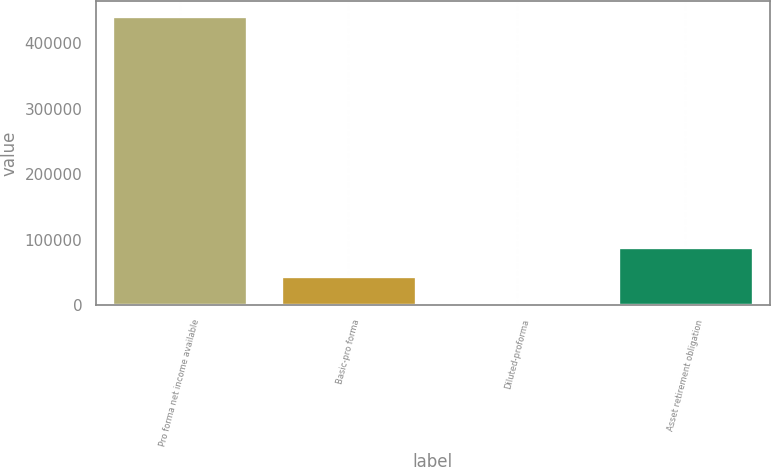Convert chart to OTSL. <chart><loc_0><loc_0><loc_500><loc_500><bar_chart><fcel>Pro forma net income available<fcel>Basic-pro forma<fcel>Diluted-proforma<fcel>Asset retirement obligation<nl><fcel>442080<fcel>44211.5<fcel>3.89<fcel>88419.1<nl></chart> 